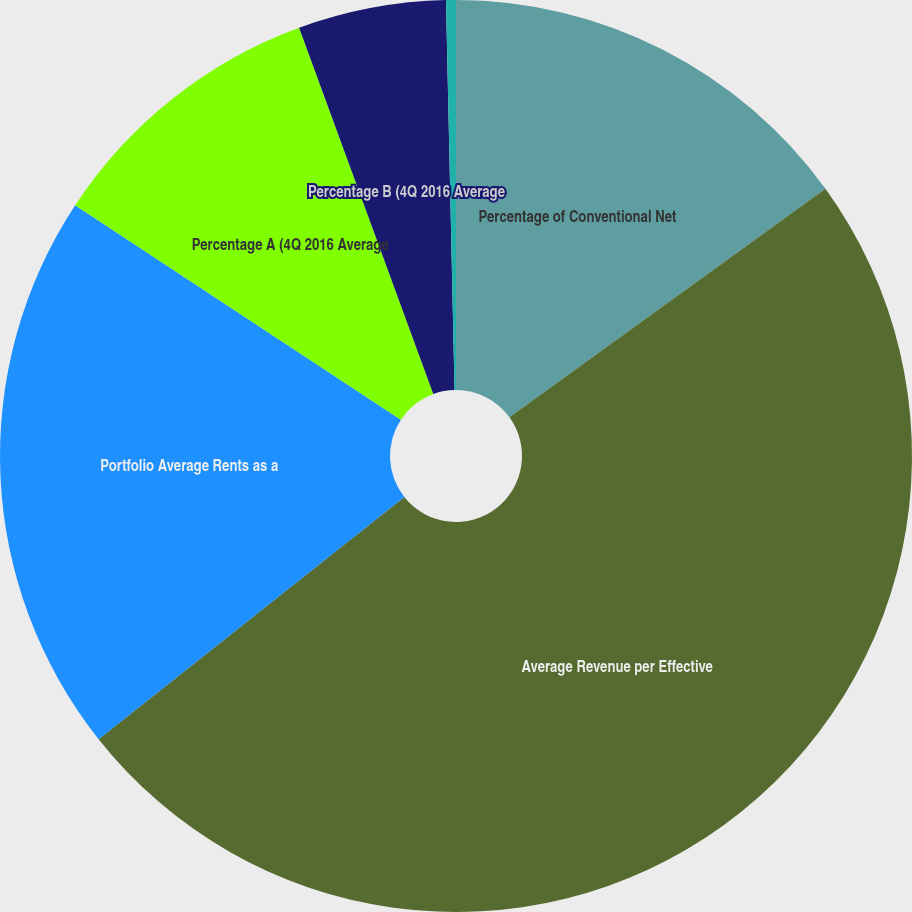Convert chart. <chart><loc_0><loc_0><loc_500><loc_500><pie_chart><fcel>Percentage of Conventional Net<fcel>Average Revenue per Effective<fcel>Portfolio Average Rents as a<fcel>Percentage A (4Q 2016 Average<fcel>Percentage B (4Q 2016 Average<fcel>Percentage C+ (4Q 2016 Average<nl><fcel>15.03%<fcel>49.3%<fcel>19.93%<fcel>10.14%<fcel>5.24%<fcel>0.35%<nl></chart> 